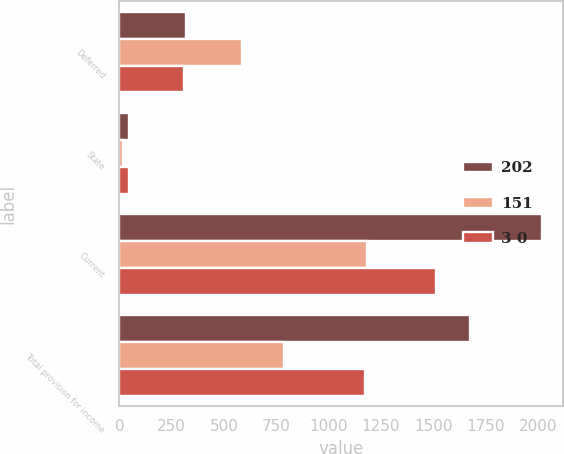<chart> <loc_0><loc_0><loc_500><loc_500><stacked_bar_chart><ecel><fcel>Deferred<fcel>State<fcel>Current<fcel>Total provision for income<nl><fcel>202<fcel>317<fcel>46<fcel>2019<fcel>1675<nl><fcel>151<fcel>588<fcel>17<fcel>1185<fcel>785<nl><fcel>3 0<fcel>309<fcel>46<fcel>1515<fcel>1173<nl></chart> 